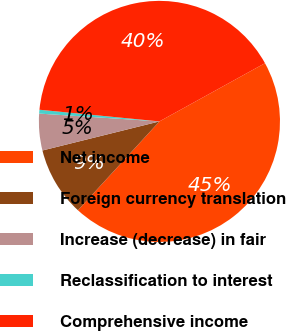Convert chart. <chart><loc_0><loc_0><loc_500><loc_500><pie_chart><fcel>Net income<fcel>Foreign currency translation<fcel>Increase (decrease) in fair<fcel>Reclassification to interest<fcel>Comprehensive income<nl><fcel>44.83%<fcel>9.31%<fcel>4.91%<fcel>0.51%<fcel>40.43%<nl></chart> 